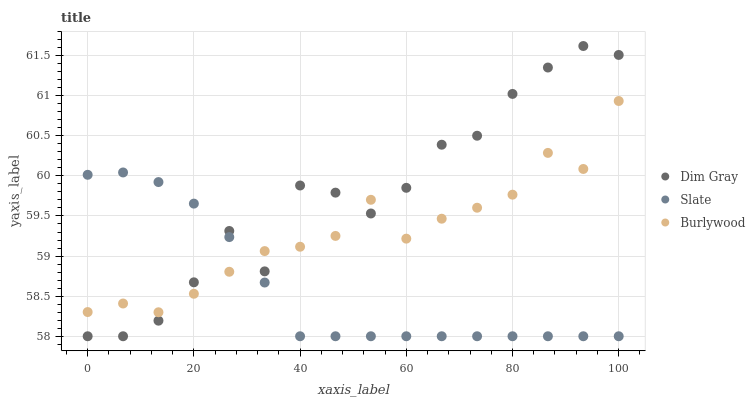Does Slate have the minimum area under the curve?
Answer yes or no. Yes. Does Dim Gray have the maximum area under the curve?
Answer yes or no. Yes. Does Dim Gray have the minimum area under the curve?
Answer yes or no. No. Does Slate have the maximum area under the curve?
Answer yes or no. No. Is Slate the smoothest?
Answer yes or no. Yes. Is Dim Gray the roughest?
Answer yes or no. Yes. Is Dim Gray the smoothest?
Answer yes or no. No. Is Slate the roughest?
Answer yes or no. No. Does Slate have the lowest value?
Answer yes or no. Yes. Does Dim Gray have the highest value?
Answer yes or no. Yes. Does Slate have the highest value?
Answer yes or no. No. Does Slate intersect Dim Gray?
Answer yes or no. Yes. Is Slate less than Dim Gray?
Answer yes or no. No. Is Slate greater than Dim Gray?
Answer yes or no. No. 